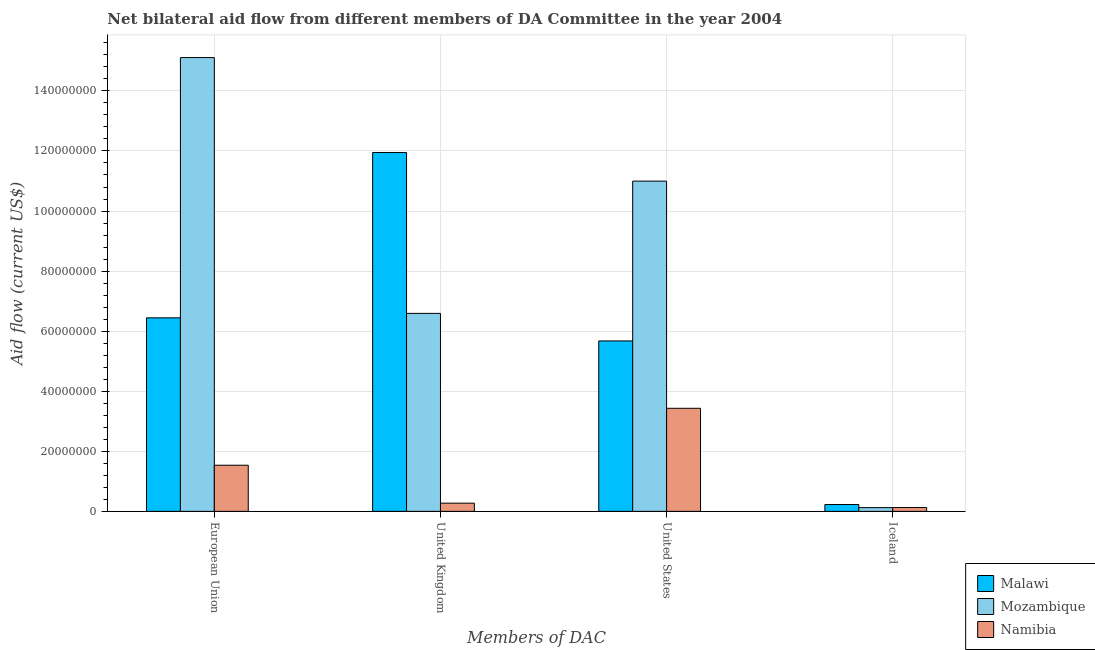How many different coloured bars are there?
Provide a short and direct response. 3. Are the number of bars on each tick of the X-axis equal?
Provide a short and direct response. Yes. How many bars are there on the 4th tick from the left?
Ensure brevity in your answer.  3. What is the amount of aid given by iceland in Namibia?
Offer a terse response. 1.27e+06. Across all countries, what is the maximum amount of aid given by iceland?
Provide a short and direct response. 2.28e+06. Across all countries, what is the minimum amount of aid given by us?
Your answer should be compact. 3.43e+07. In which country was the amount of aid given by uk maximum?
Offer a very short reply. Malawi. In which country was the amount of aid given by iceland minimum?
Make the answer very short. Mozambique. What is the total amount of aid given by uk in the graph?
Ensure brevity in your answer.  1.88e+08. What is the difference between the amount of aid given by uk in Namibia and that in Mozambique?
Your answer should be compact. -6.32e+07. What is the difference between the amount of aid given by uk in Mozambique and the amount of aid given by eu in Malawi?
Your response must be concise. 1.48e+06. What is the average amount of aid given by eu per country?
Offer a very short reply. 7.70e+07. What is the difference between the amount of aid given by eu and amount of aid given by us in Malawi?
Your response must be concise. 7.69e+06. What is the ratio of the amount of aid given by us in Malawi to that in Mozambique?
Give a very brief answer. 0.52. What is the difference between the highest and the second highest amount of aid given by us?
Ensure brevity in your answer.  5.32e+07. What is the difference between the highest and the lowest amount of aid given by uk?
Give a very brief answer. 1.17e+08. In how many countries, is the amount of aid given by uk greater than the average amount of aid given by uk taken over all countries?
Your answer should be compact. 2. What does the 2nd bar from the left in United Kingdom represents?
Your answer should be compact. Mozambique. What does the 1st bar from the right in Iceland represents?
Give a very brief answer. Namibia. Are the values on the major ticks of Y-axis written in scientific E-notation?
Your response must be concise. No. Does the graph contain any zero values?
Offer a terse response. No. Where does the legend appear in the graph?
Make the answer very short. Bottom right. What is the title of the graph?
Make the answer very short. Net bilateral aid flow from different members of DA Committee in the year 2004. What is the label or title of the X-axis?
Offer a terse response. Members of DAC. What is the label or title of the Y-axis?
Your response must be concise. Aid flow (current US$). What is the Aid flow (current US$) in Malawi in European Union?
Provide a short and direct response. 6.44e+07. What is the Aid flow (current US$) of Mozambique in European Union?
Give a very brief answer. 1.51e+08. What is the Aid flow (current US$) of Namibia in European Union?
Ensure brevity in your answer.  1.54e+07. What is the Aid flow (current US$) in Malawi in United Kingdom?
Provide a short and direct response. 1.20e+08. What is the Aid flow (current US$) of Mozambique in United Kingdom?
Keep it short and to the point. 6.59e+07. What is the Aid flow (current US$) of Namibia in United Kingdom?
Give a very brief answer. 2.73e+06. What is the Aid flow (current US$) in Malawi in United States?
Your response must be concise. 5.68e+07. What is the Aid flow (current US$) of Mozambique in United States?
Offer a terse response. 1.10e+08. What is the Aid flow (current US$) in Namibia in United States?
Your answer should be compact. 3.43e+07. What is the Aid flow (current US$) of Malawi in Iceland?
Offer a very short reply. 2.28e+06. What is the Aid flow (current US$) in Mozambique in Iceland?
Your response must be concise. 1.24e+06. What is the Aid flow (current US$) in Namibia in Iceland?
Provide a short and direct response. 1.27e+06. Across all Members of DAC, what is the maximum Aid flow (current US$) of Malawi?
Your response must be concise. 1.20e+08. Across all Members of DAC, what is the maximum Aid flow (current US$) in Mozambique?
Your answer should be very brief. 1.51e+08. Across all Members of DAC, what is the maximum Aid flow (current US$) in Namibia?
Offer a very short reply. 3.43e+07. Across all Members of DAC, what is the minimum Aid flow (current US$) of Malawi?
Provide a succinct answer. 2.28e+06. Across all Members of DAC, what is the minimum Aid flow (current US$) in Mozambique?
Offer a very short reply. 1.24e+06. Across all Members of DAC, what is the minimum Aid flow (current US$) of Namibia?
Give a very brief answer. 1.27e+06. What is the total Aid flow (current US$) of Malawi in the graph?
Offer a terse response. 2.43e+08. What is the total Aid flow (current US$) of Mozambique in the graph?
Keep it short and to the point. 3.28e+08. What is the total Aid flow (current US$) in Namibia in the graph?
Offer a very short reply. 5.37e+07. What is the difference between the Aid flow (current US$) of Malawi in European Union and that in United Kingdom?
Give a very brief answer. -5.51e+07. What is the difference between the Aid flow (current US$) in Mozambique in European Union and that in United Kingdom?
Give a very brief answer. 8.52e+07. What is the difference between the Aid flow (current US$) of Namibia in European Union and that in United Kingdom?
Make the answer very short. 1.26e+07. What is the difference between the Aid flow (current US$) of Malawi in European Union and that in United States?
Offer a very short reply. 7.69e+06. What is the difference between the Aid flow (current US$) in Mozambique in European Union and that in United States?
Give a very brief answer. 4.11e+07. What is the difference between the Aid flow (current US$) in Namibia in European Union and that in United States?
Keep it short and to the point. -1.90e+07. What is the difference between the Aid flow (current US$) in Malawi in European Union and that in Iceland?
Your answer should be very brief. 6.22e+07. What is the difference between the Aid flow (current US$) of Mozambique in European Union and that in Iceland?
Offer a very short reply. 1.50e+08. What is the difference between the Aid flow (current US$) in Namibia in European Union and that in Iceland?
Your answer should be compact. 1.41e+07. What is the difference between the Aid flow (current US$) in Malawi in United Kingdom and that in United States?
Ensure brevity in your answer.  6.28e+07. What is the difference between the Aid flow (current US$) in Mozambique in United Kingdom and that in United States?
Provide a succinct answer. -4.40e+07. What is the difference between the Aid flow (current US$) in Namibia in United Kingdom and that in United States?
Give a very brief answer. -3.16e+07. What is the difference between the Aid flow (current US$) of Malawi in United Kingdom and that in Iceland?
Provide a succinct answer. 1.17e+08. What is the difference between the Aid flow (current US$) in Mozambique in United Kingdom and that in Iceland?
Ensure brevity in your answer.  6.47e+07. What is the difference between the Aid flow (current US$) of Namibia in United Kingdom and that in Iceland?
Keep it short and to the point. 1.46e+06. What is the difference between the Aid flow (current US$) in Malawi in United States and that in Iceland?
Provide a short and direct response. 5.45e+07. What is the difference between the Aid flow (current US$) of Mozambique in United States and that in Iceland?
Ensure brevity in your answer.  1.09e+08. What is the difference between the Aid flow (current US$) of Namibia in United States and that in Iceland?
Offer a very short reply. 3.30e+07. What is the difference between the Aid flow (current US$) in Malawi in European Union and the Aid flow (current US$) in Mozambique in United Kingdom?
Offer a terse response. -1.48e+06. What is the difference between the Aid flow (current US$) in Malawi in European Union and the Aid flow (current US$) in Namibia in United Kingdom?
Provide a short and direct response. 6.17e+07. What is the difference between the Aid flow (current US$) of Mozambique in European Union and the Aid flow (current US$) of Namibia in United Kingdom?
Your answer should be compact. 1.48e+08. What is the difference between the Aid flow (current US$) of Malawi in European Union and the Aid flow (current US$) of Mozambique in United States?
Your answer should be very brief. -4.55e+07. What is the difference between the Aid flow (current US$) in Malawi in European Union and the Aid flow (current US$) in Namibia in United States?
Ensure brevity in your answer.  3.01e+07. What is the difference between the Aid flow (current US$) in Mozambique in European Union and the Aid flow (current US$) in Namibia in United States?
Provide a succinct answer. 1.17e+08. What is the difference between the Aid flow (current US$) in Malawi in European Union and the Aid flow (current US$) in Mozambique in Iceland?
Your response must be concise. 6.32e+07. What is the difference between the Aid flow (current US$) in Malawi in European Union and the Aid flow (current US$) in Namibia in Iceland?
Offer a terse response. 6.32e+07. What is the difference between the Aid flow (current US$) of Mozambique in European Union and the Aid flow (current US$) of Namibia in Iceland?
Offer a terse response. 1.50e+08. What is the difference between the Aid flow (current US$) of Malawi in United Kingdom and the Aid flow (current US$) of Mozambique in United States?
Make the answer very short. 9.54e+06. What is the difference between the Aid flow (current US$) in Malawi in United Kingdom and the Aid flow (current US$) in Namibia in United States?
Make the answer very short. 8.52e+07. What is the difference between the Aid flow (current US$) in Mozambique in United Kingdom and the Aid flow (current US$) in Namibia in United States?
Keep it short and to the point. 3.16e+07. What is the difference between the Aid flow (current US$) of Malawi in United Kingdom and the Aid flow (current US$) of Mozambique in Iceland?
Offer a very short reply. 1.18e+08. What is the difference between the Aid flow (current US$) of Malawi in United Kingdom and the Aid flow (current US$) of Namibia in Iceland?
Provide a succinct answer. 1.18e+08. What is the difference between the Aid flow (current US$) in Mozambique in United Kingdom and the Aid flow (current US$) in Namibia in Iceland?
Offer a very short reply. 6.46e+07. What is the difference between the Aid flow (current US$) in Malawi in United States and the Aid flow (current US$) in Mozambique in Iceland?
Offer a terse response. 5.55e+07. What is the difference between the Aid flow (current US$) in Malawi in United States and the Aid flow (current US$) in Namibia in Iceland?
Your response must be concise. 5.55e+07. What is the difference between the Aid flow (current US$) in Mozambique in United States and the Aid flow (current US$) in Namibia in Iceland?
Ensure brevity in your answer.  1.09e+08. What is the average Aid flow (current US$) of Malawi per Members of DAC?
Your answer should be compact. 6.07e+07. What is the average Aid flow (current US$) in Mozambique per Members of DAC?
Provide a short and direct response. 8.21e+07. What is the average Aid flow (current US$) of Namibia per Members of DAC?
Your answer should be very brief. 1.34e+07. What is the difference between the Aid flow (current US$) of Malawi and Aid flow (current US$) of Mozambique in European Union?
Your answer should be compact. -8.67e+07. What is the difference between the Aid flow (current US$) of Malawi and Aid flow (current US$) of Namibia in European Union?
Give a very brief answer. 4.91e+07. What is the difference between the Aid flow (current US$) in Mozambique and Aid flow (current US$) in Namibia in European Union?
Provide a short and direct response. 1.36e+08. What is the difference between the Aid flow (current US$) in Malawi and Aid flow (current US$) in Mozambique in United Kingdom?
Offer a very short reply. 5.36e+07. What is the difference between the Aid flow (current US$) in Malawi and Aid flow (current US$) in Namibia in United Kingdom?
Give a very brief answer. 1.17e+08. What is the difference between the Aid flow (current US$) of Mozambique and Aid flow (current US$) of Namibia in United Kingdom?
Provide a short and direct response. 6.32e+07. What is the difference between the Aid flow (current US$) of Malawi and Aid flow (current US$) of Mozambique in United States?
Provide a succinct answer. -5.32e+07. What is the difference between the Aid flow (current US$) in Malawi and Aid flow (current US$) in Namibia in United States?
Provide a succinct answer. 2.24e+07. What is the difference between the Aid flow (current US$) in Mozambique and Aid flow (current US$) in Namibia in United States?
Your answer should be very brief. 7.56e+07. What is the difference between the Aid flow (current US$) in Malawi and Aid flow (current US$) in Mozambique in Iceland?
Your answer should be compact. 1.04e+06. What is the difference between the Aid flow (current US$) of Malawi and Aid flow (current US$) of Namibia in Iceland?
Offer a terse response. 1.01e+06. What is the difference between the Aid flow (current US$) of Mozambique and Aid flow (current US$) of Namibia in Iceland?
Give a very brief answer. -3.00e+04. What is the ratio of the Aid flow (current US$) of Malawi in European Union to that in United Kingdom?
Provide a short and direct response. 0.54. What is the ratio of the Aid flow (current US$) in Mozambique in European Union to that in United Kingdom?
Your response must be concise. 2.29. What is the ratio of the Aid flow (current US$) of Namibia in European Union to that in United Kingdom?
Offer a very short reply. 5.63. What is the ratio of the Aid flow (current US$) of Malawi in European Union to that in United States?
Ensure brevity in your answer.  1.14. What is the ratio of the Aid flow (current US$) in Mozambique in European Union to that in United States?
Offer a terse response. 1.37. What is the ratio of the Aid flow (current US$) of Namibia in European Union to that in United States?
Your response must be concise. 0.45. What is the ratio of the Aid flow (current US$) of Malawi in European Union to that in Iceland?
Offer a very short reply. 28.26. What is the ratio of the Aid flow (current US$) of Mozambique in European Union to that in Iceland?
Make the answer very short. 121.85. What is the ratio of the Aid flow (current US$) of Namibia in European Union to that in Iceland?
Make the answer very short. 12.09. What is the ratio of the Aid flow (current US$) of Malawi in United Kingdom to that in United States?
Offer a terse response. 2.11. What is the ratio of the Aid flow (current US$) in Mozambique in United Kingdom to that in United States?
Make the answer very short. 0.6. What is the ratio of the Aid flow (current US$) in Namibia in United Kingdom to that in United States?
Make the answer very short. 0.08. What is the ratio of the Aid flow (current US$) of Malawi in United Kingdom to that in Iceland?
Make the answer very short. 52.41. What is the ratio of the Aid flow (current US$) in Mozambique in United Kingdom to that in Iceland?
Give a very brief answer. 53.16. What is the ratio of the Aid flow (current US$) in Namibia in United Kingdom to that in Iceland?
Ensure brevity in your answer.  2.15. What is the ratio of the Aid flow (current US$) in Malawi in United States to that in Iceland?
Give a very brief answer. 24.89. What is the ratio of the Aid flow (current US$) in Mozambique in United States to that in Iceland?
Provide a short and direct response. 88.68. What is the ratio of the Aid flow (current US$) in Namibia in United States to that in Iceland?
Your answer should be very brief. 27.02. What is the difference between the highest and the second highest Aid flow (current US$) of Malawi?
Make the answer very short. 5.51e+07. What is the difference between the highest and the second highest Aid flow (current US$) of Mozambique?
Provide a short and direct response. 4.11e+07. What is the difference between the highest and the second highest Aid flow (current US$) of Namibia?
Your response must be concise. 1.90e+07. What is the difference between the highest and the lowest Aid flow (current US$) in Malawi?
Your answer should be very brief. 1.17e+08. What is the difference between the highest and the lowest Aid flow (current US$) in Mozambique?
Your response must be concise. 1.50e+08. What is the difference between the highest and the lowest Aid flow (current US$) of Namibia?
Offer a very short reply. 3.30e+07. 